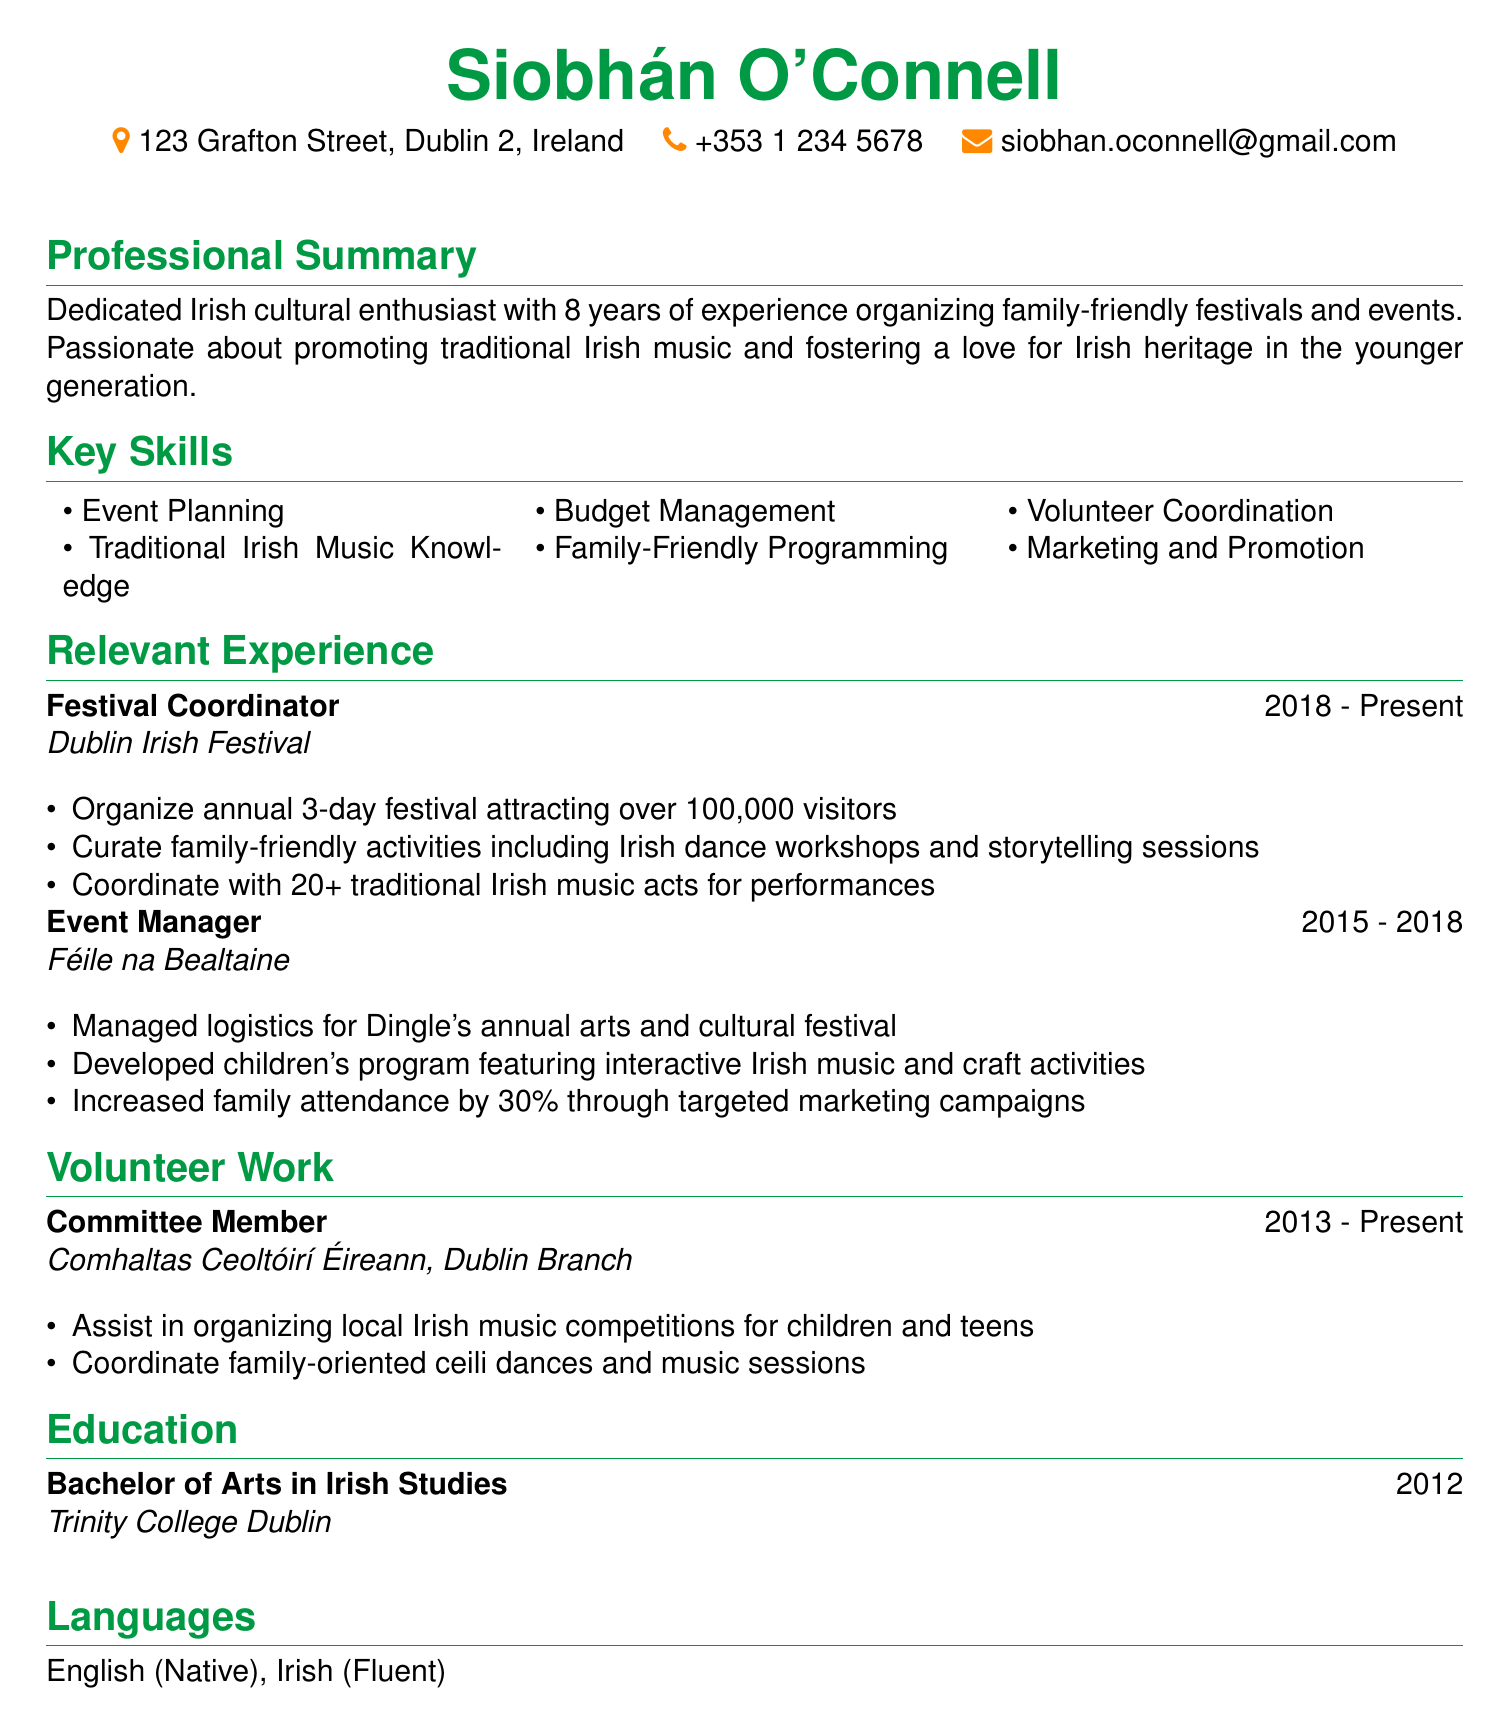What is the name of the individual? The name of the individual is provided in the personal information section.
Answer: Siobhán O'Connell What is the duration of Siobhán's role as Festival Coordinator? The duration is stated under the relevant experience section for the role of Festival Coordinator.
Answer: 2018 - Present What is the educational degree Siobhán holds? This information is found in the education section of the CV.
Answer: Bachelor of Arts in Irish Studies How many visitors does the Dublin Irish Festival attract? This detail is mentioned in the responsibilities of the Festival Coordinator role.
Answer: Over 100,000 visitors What percentage increase in family attendance did Siobhán achieve at Féile na Bealtaine? The specific percentage is indicated in the experience section regarding her role as Event Manager.
Answer: 30% What organization does Siobhán volunteer with? The volunteering details are listed in the volunteer work section.
Answer: Comhaltas Ceoltóirí Éireann, Dublin Branch What type of programming does Siobhán curate for the Dublin Irish Festival? This question relates to the responsibilities described for the Festival Coordinator position.
Answer: Family-friendly activities How many traditional Irish music acts does Siobhán coordinate with? This number can be found in the relevant experience section under Festival Coordinator.
Answer: 20+ In which city does Siobhán reside? This information is located in the personal info section of the CV.
Answer: Dublin 